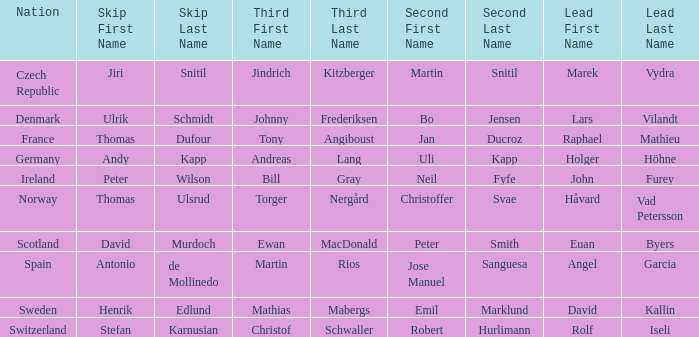Which Lead has a Nation of switzerland? Rolf Iseli. 